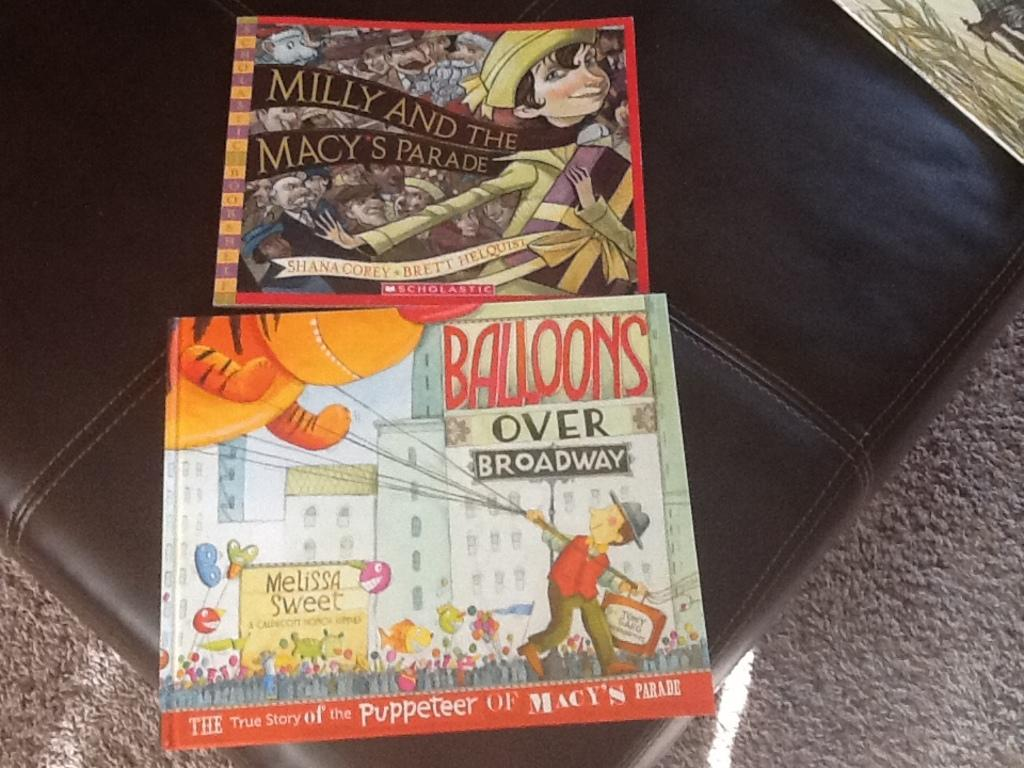<image>
Relay a brief, clear account of the picture shown. Two books, "Balloons Over Broadway" and "Milly and the Macy's Parade," sit on the couch. 